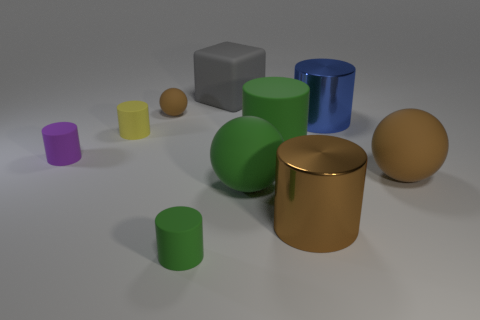There is a shiny cylinder that is the same color as the tiny rubber ball; what is its size?
Make the answer very short. Large. What is the large gray cube made of?
Ensure brevity in your answer.  Rubber. Does the tiny green thing have the same material as the big green thing that is behind the purple matte cylinder?
Offer a terse response. Yes. There is a large metal cylinder behind the metal cylinder that is in front of the small yellow thing; what is its color?
Keep it short and to the point. Blue. There is a cylinder that is both right of the gray rubber object and to the left of the big brown cylinder; what is its size?
Provide a succinct answer. Large. How many other things are there of the same shape as the small brown rubber object?
Your answer should be compact. 2. There is a blue metallic thing; is its shape the same as the big brown thing that is behind the large brown cylinder?
Your answer should be compact. No. What number of large green objects are behind the tiny sphere?
Ensure brevity in your answer.  0. Are there any other things that are made of the same material as the tiny purple cylinder?
Offer a terse response. Yes. Does the shiny thing that is in front of the small yellow matte cylinder have the same shape as the purple object?
Provide a short and direct response. Yes. 